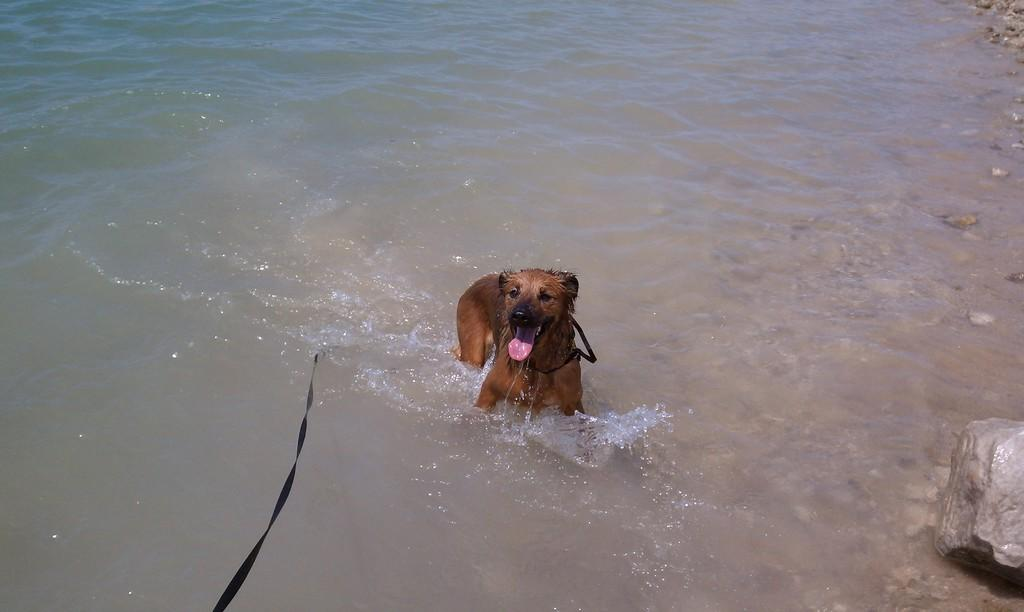What animal is present in the image? There is a dog in the image. Where is the dog located in the image? The dog is in the water. What type of lamp is floating next to the dog in the image? There is no lamp present in the image; it only features a dog in the water. 